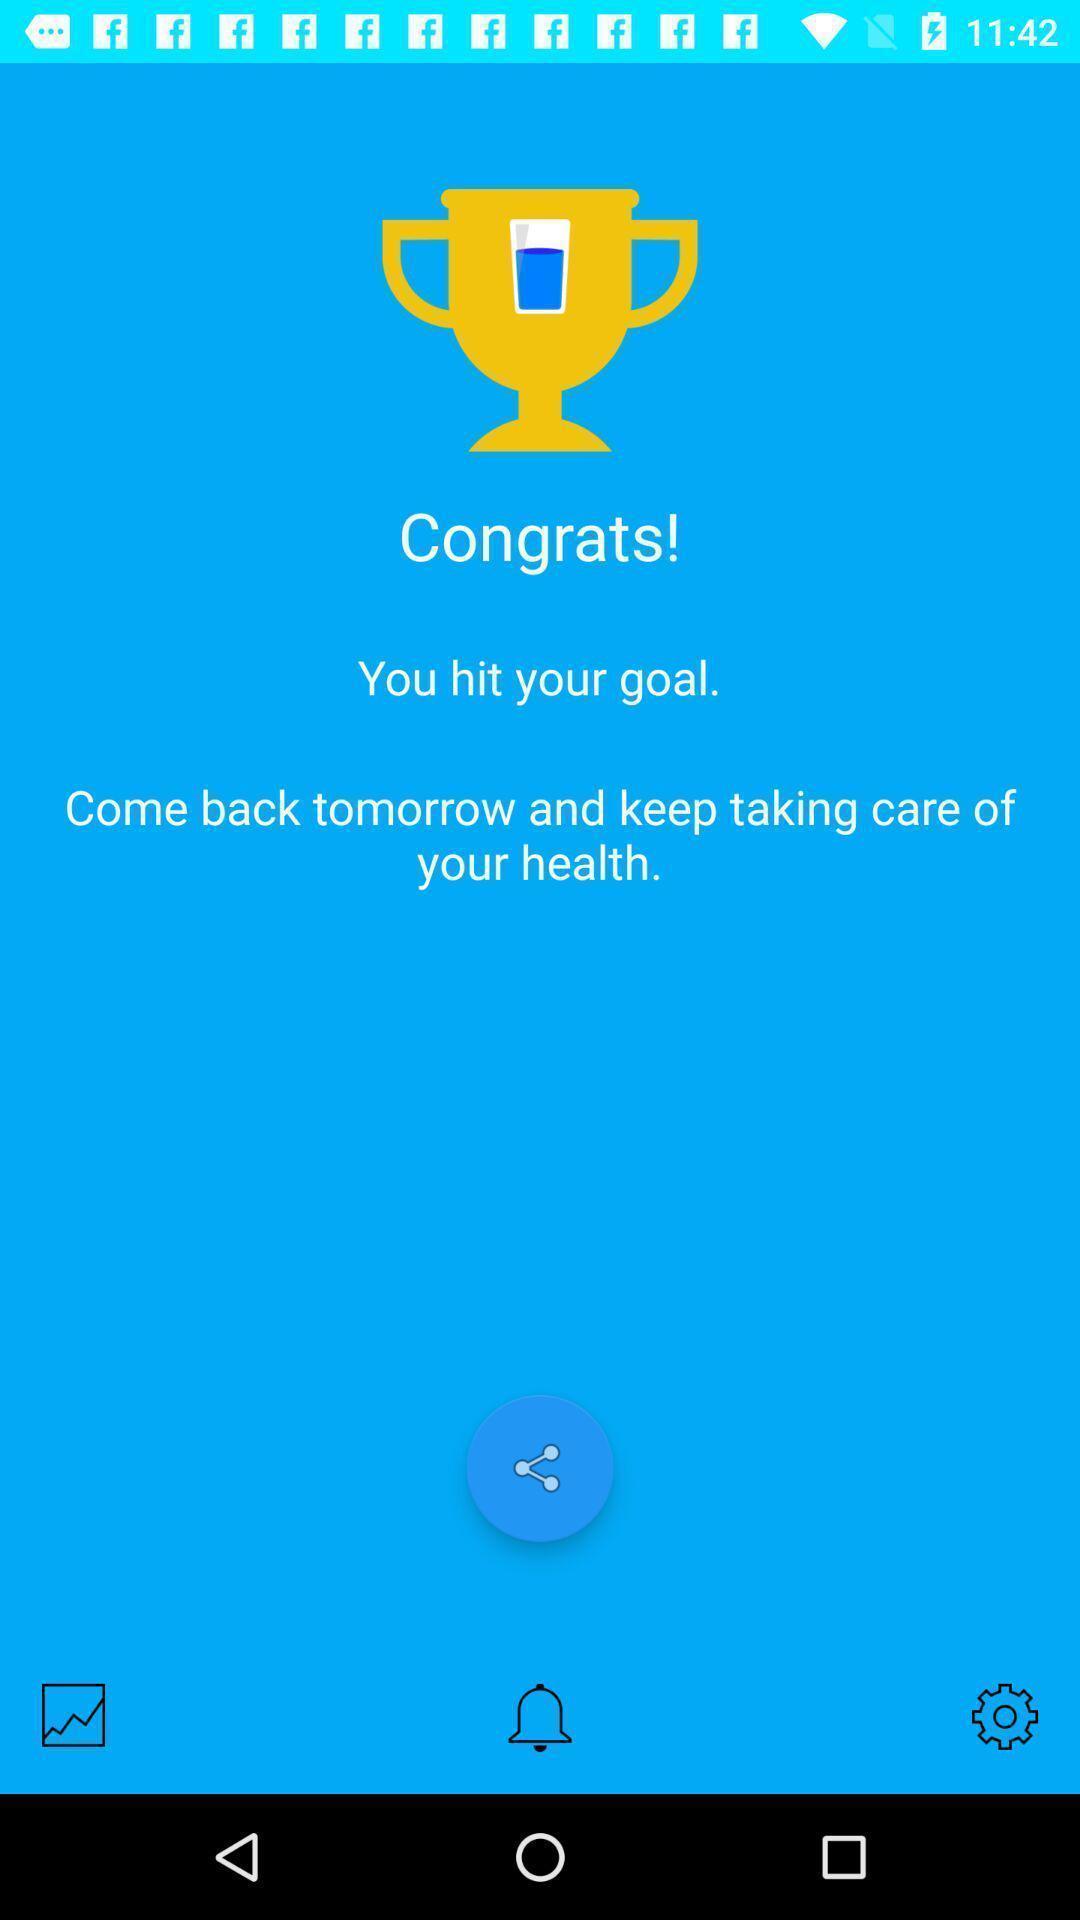Provide a detailed account of this screenshot. Page displays congrats for hitting goal in app. 